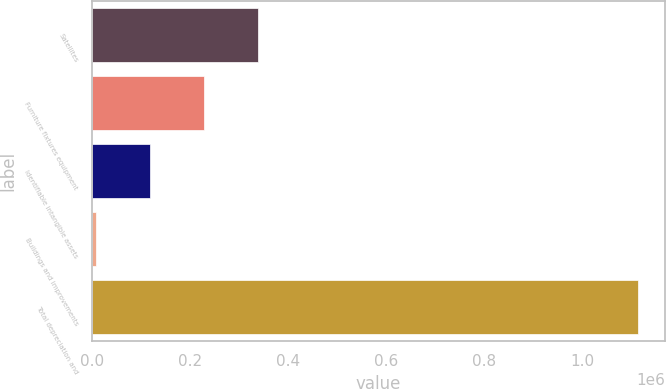Convert chart. <chart><loc_0><loc_0><loc_500><loc_500><bar_chart><fcel>Satellites<fcel>Furniture fixtures equipment<fcel>Identifiable intangible assets<fcel>Buildings and improvements<fcel>Total depreciation and<nl><fcel>339329<fcel>228620<fcel>117910<fcel>7201<fcel>1.11429e+06<nl></chart> 